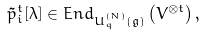<formula> <loc_0><loc_0><loc_500><loc_500>\tilde { p } _ { i } ^ { t } [ \lambda ] \in E n d _ { U ^ { ( N ) } _ { q } ( \mathfrak { g } ) } \left ( V ^ { \otimes t } \right ) ,</formula> 